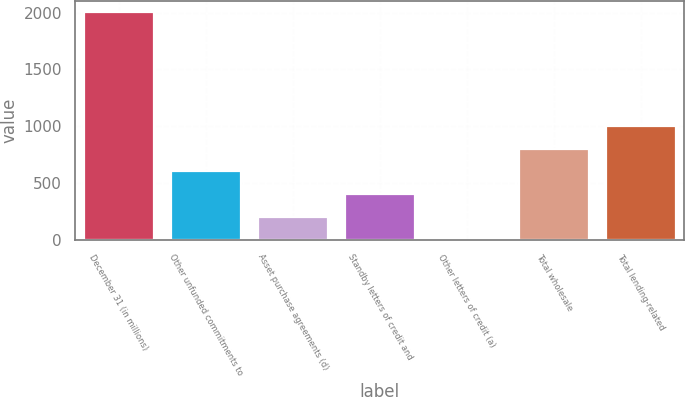<chart> <loc_0><loc_0><loc_500><loc_500><bar_chart><fcel>December 31 (in millions)<fcel>Other unfunded commitments to<fcel>Asset purchase agreements (d)<fcel>Standby letters of credit and<fcel>Other letters of credit (a)<fcel>Total wholesale<fcel>Total lending-related<nl><fcel>2005<fcel>602.2<fcel>201.4<fcel>401.8<fcel>1<fcel>802.6<fcel>1003<nl></chart> 